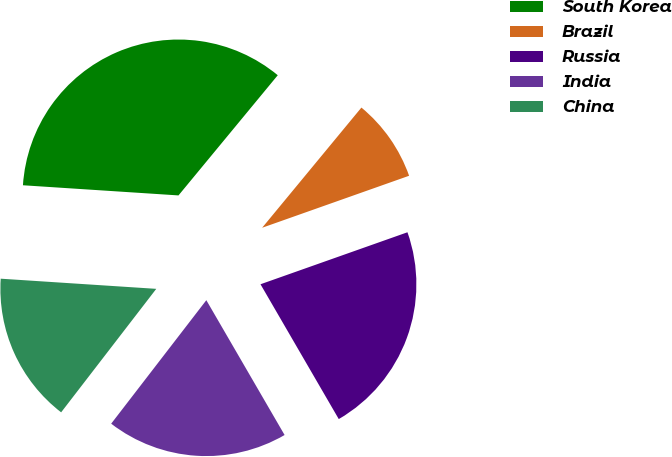Convert chart. <chart><loc_0><loc_0><loc_500><loc_500><pie_chart><fcel>South Korea<fcel>Brazil<fcel>Russia<fcel>India<fcel>China<nl><fcel>34.95%<fcel>8.6%<fcel>22.04%<fcel>18.82%<fcel>15.59%<nl></chart> 